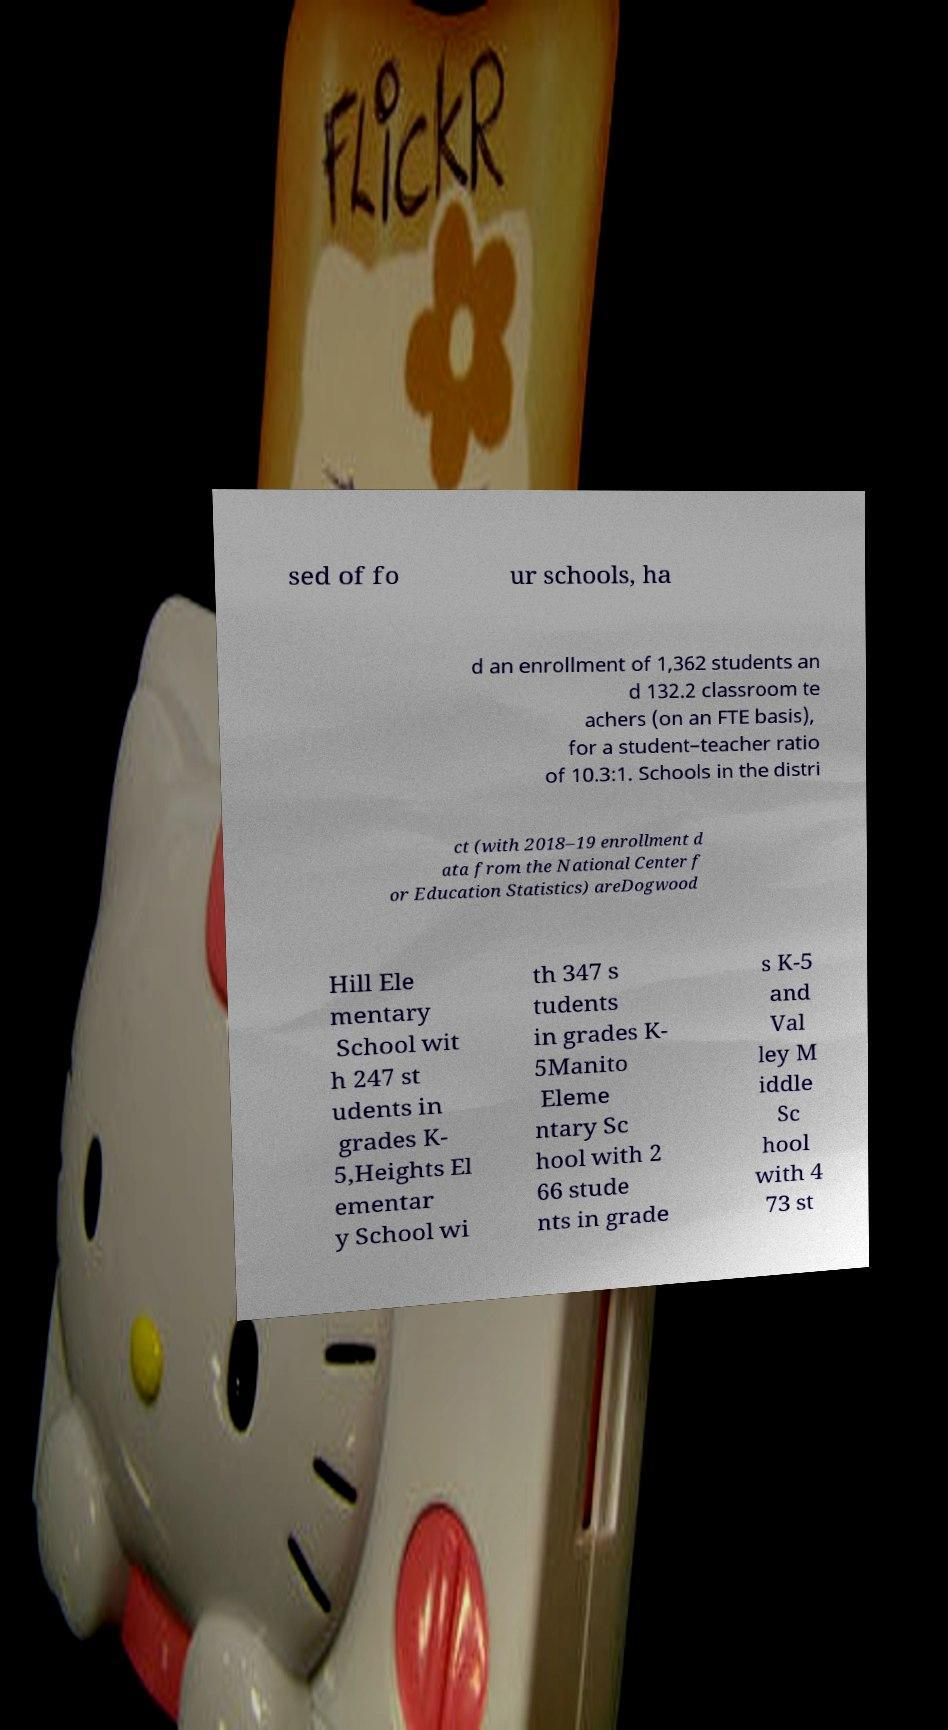I need the written content from this picture converted into text. Can you do that? sed of fo ur schools, ha d an enrollment of 1,362 students an d 132.2 classroom te achers (on an FTE basis), for a student–teacher ratio of 10.3:1. Schools in the distri ct (with 2018–19 enrollment d ata from the National Center f or Education Statistics) areDogwood Hill Ele mentary School wit h 247 st udents in grades K- 5,Heights El ementar y School wi th 347 s tudents in grades K- 5Manito Eleme ntary Sc hool with 2 66 stude nts in grade s K-5 and Val ley M iddle Sc hool with 4 73 st 